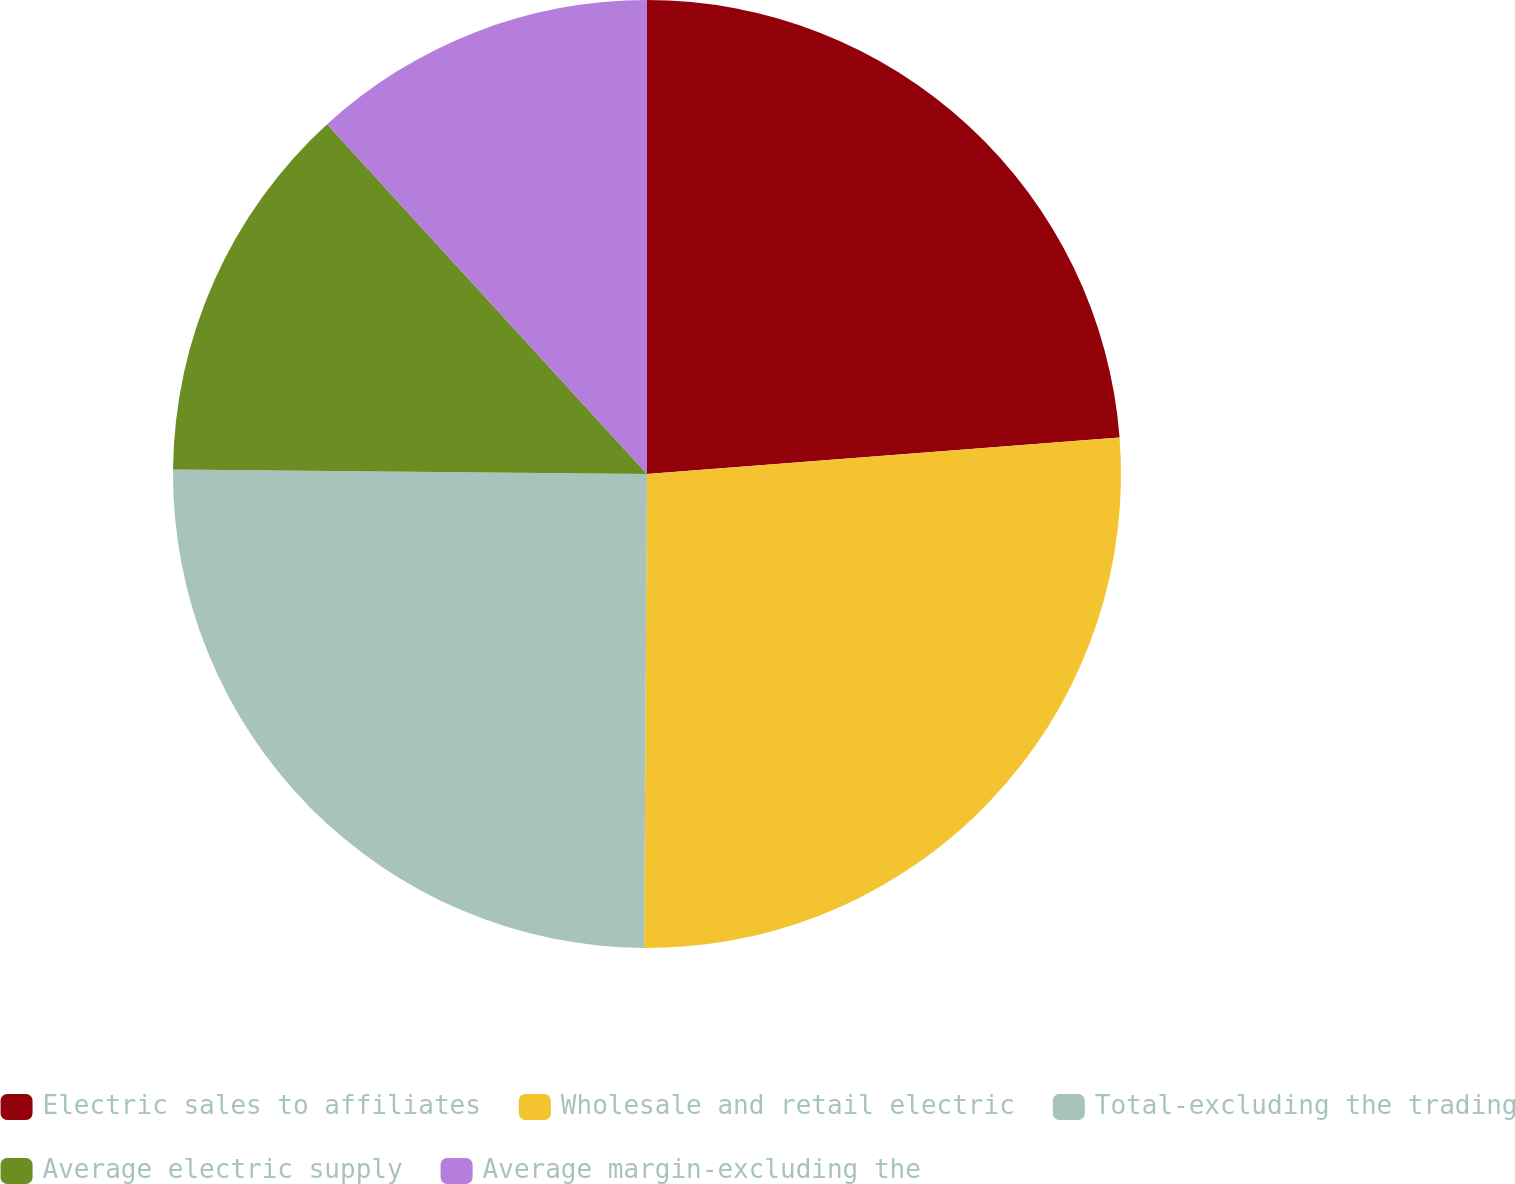Convert chart. <chart><loc_0><loc_0><loc_500><loc_500><pie_chart><fcel>Electric sales to affiliates<fcel>Wholesale and retail electric<fcel>Total-excluding the trading<fcel>Average electric supply<fcel>Average margin-excluding the<nl><fcel>23.77%<fcel>26.32%<fcel>25.05%<fcel>13.06%<fcel>11.79%<nl></chart> 